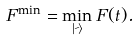<formula> <loc_0><loc_0><loc_500><loc_500>F ^ { \min } = \min _ { | \psi \rangle } F ( t ) .</formula> 